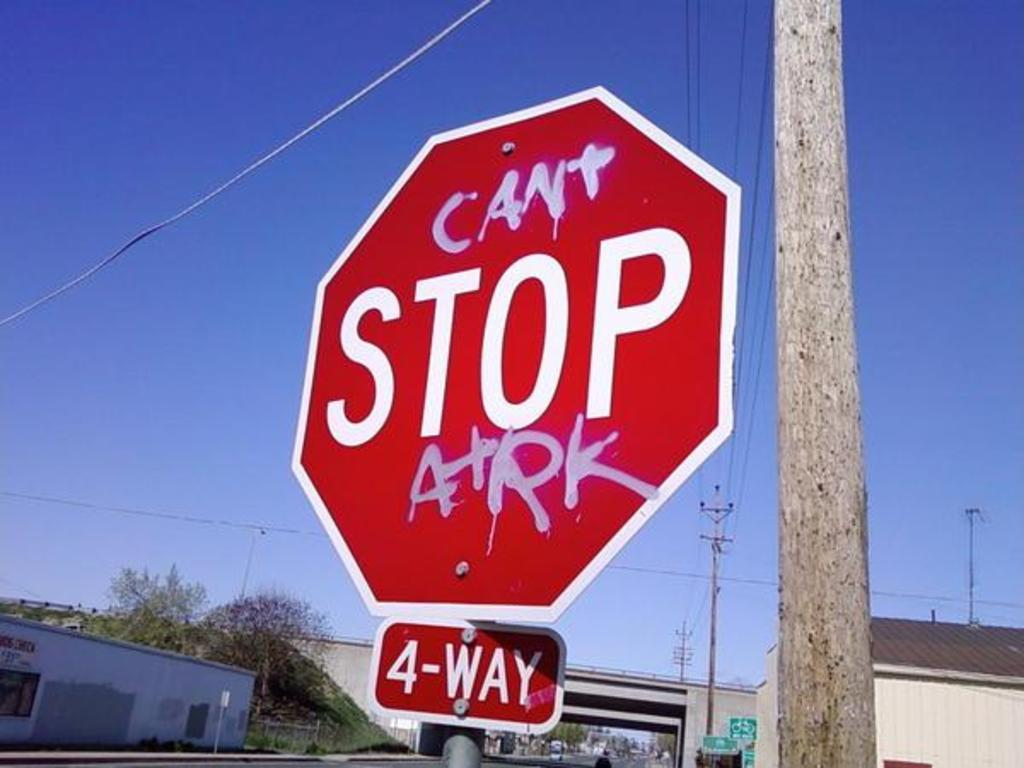Provide a one-sentence caption for the provided image. A four way stop sign with graffiti on it. 